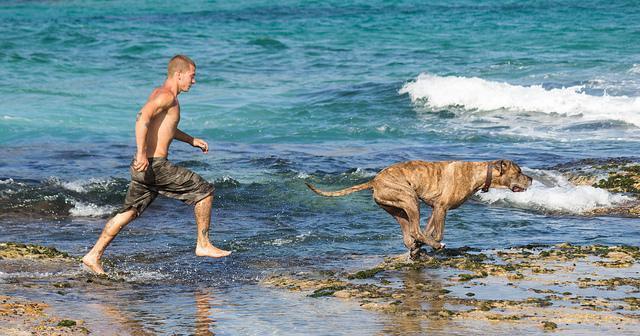How many chairs match the table top?
Give a very brief answer. 0. 